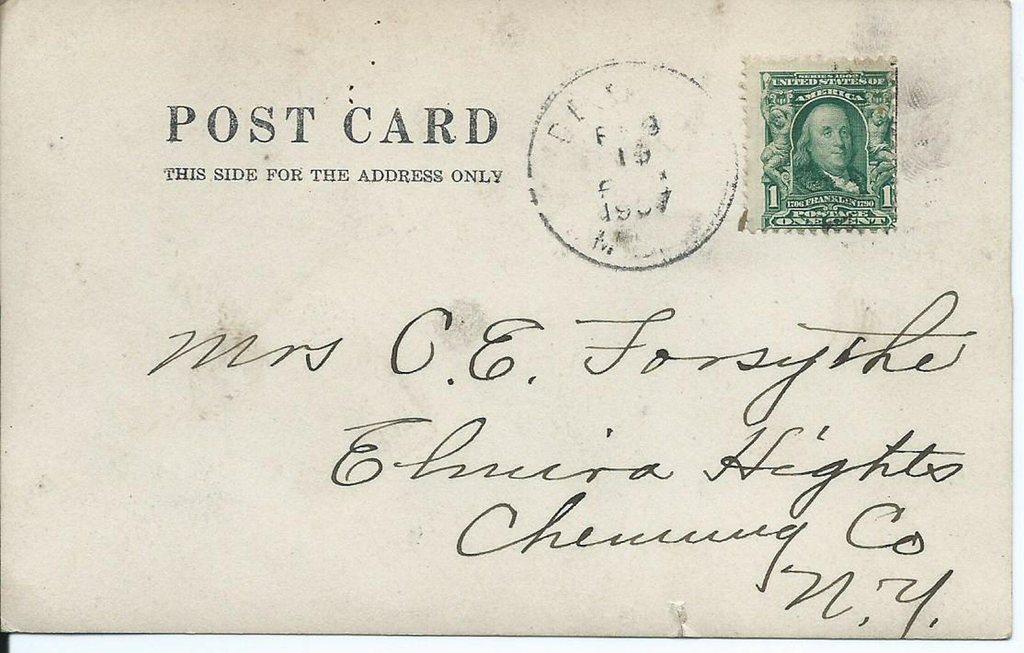What does it say this post card is for?
Your response must be concise. Address only. Who is the post card addressed to?
Provide a short and direct response. Mrs. c.e. forsythe. 